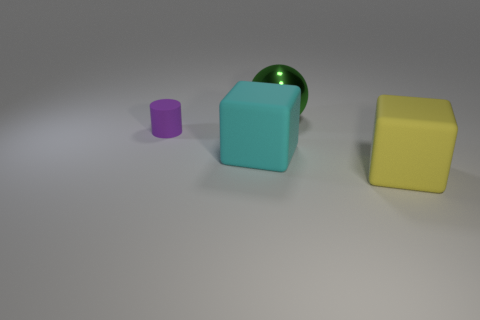Does the metal thing have the same color as the small cylinder?
Give a very brief answer. No. What color is the large ball?
Give a very brief answer. Green. How many matte things are tiny purple things or big cyan things?
Ensure brevity in your answer.  2. What is the color of the other big thing that is the same shape as the cyan object?
Your response must be concise. Yellow. Are there any big cyan objects?
Provide a succinct answer. Yes. Are the block that is on the left side of the green ball and the block on the right side of the big green object made of the same material?
Ensure brevity in your answer.  Yes. How many things are matte things on the left side of the big green metallic thing or big rubber blocks on the left side of the green metal sphere?
Your answer should be very brief. 2. There is a rubber thing that is to the right of the big green metallic thing; does it have the same color as the rubber block that is on the left side of the big green thing?
Your answer should be compact. No. There is a thing that is both to the right of the cyan matte object and in front of the large sphere; what is its shape?
Offer a very short reply. Cube. What is the color of the metal thing that is the same size as the cyan matte block?
Your answer should be very brief. Green. 